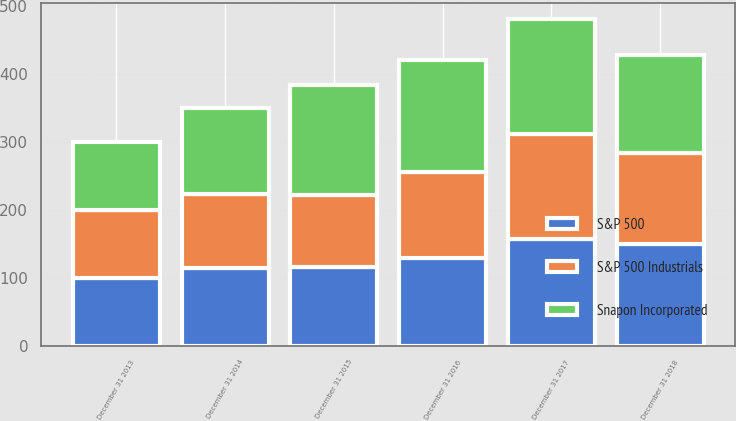Convert chart. <chart><loc_0><loc_0><loc_500><loc_500><stacked_bar_chart><ecel><fcel>December 31 2013<fcel>December 31 2014<fcel>December 31 2015<fcel>December 31 2016<fcel>December 31 2017<fcel>December 31 2018<nl><fcel>Snapon Incorporated<fcel>100<fcel>126.77<fcel>161.15<fcel>163.63<fcel>169.61<fcel>144.41<nl><fcel>S&P 500 Industrials<fcel>100<fcel>109.83<fcel>107.04<fcel>127.23<fcel>153.99<fcel>133.53<nl><fcel>S&P 500<fcel>100<fcel>113.69<fcel>115.26<fcel>129.05<fcel>157.22<fcel>150.33<nl></chart> 